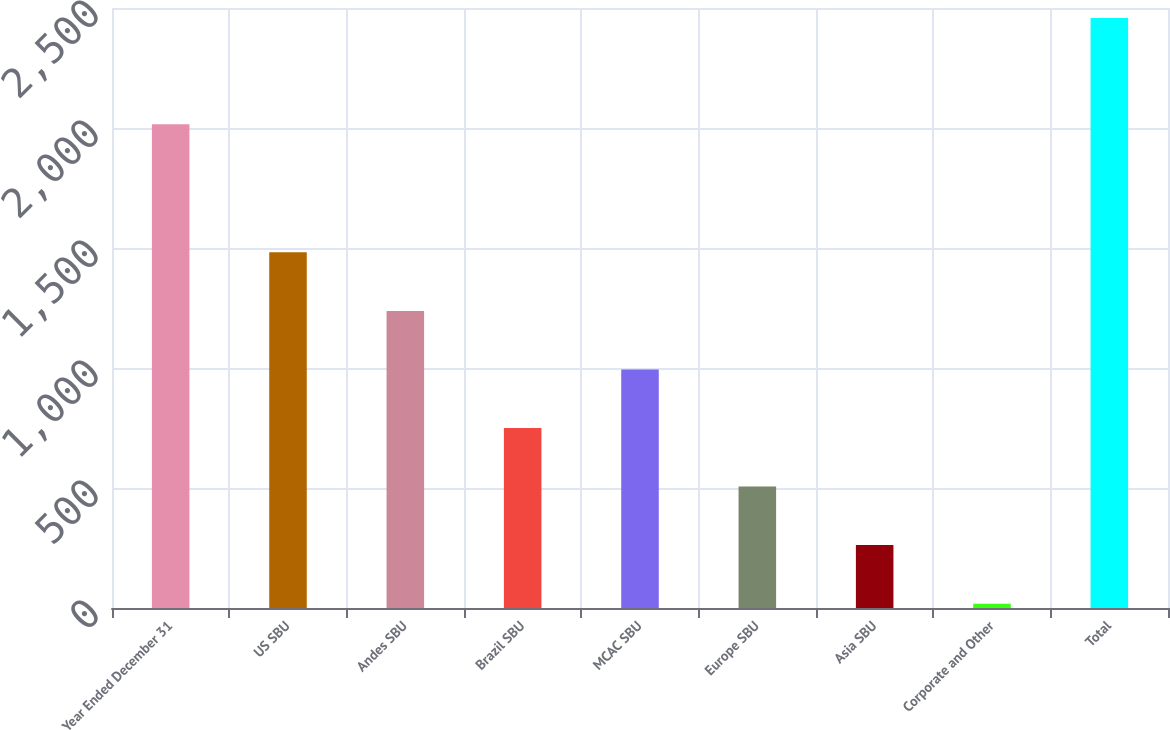Convert chart to OTSL. <chart><loc_0><loc_0><loc_500><loc_500><bar_chart><fcel>Year Ended December 31<fcel>US SBU<fcel>Andes SBU<fcel>Brazil SBU<fcel>MCAC SBU<fcel>Europe SBU<fcel>Asia SBU<fcel>Corporate and Other<fcel>Total<nl><fcel>2016<fcel>1482<fcel>1238<fcel>750<fcel>994<fcel>506<fcel>262<fcel>18<fcel>2458<nl></chart> 